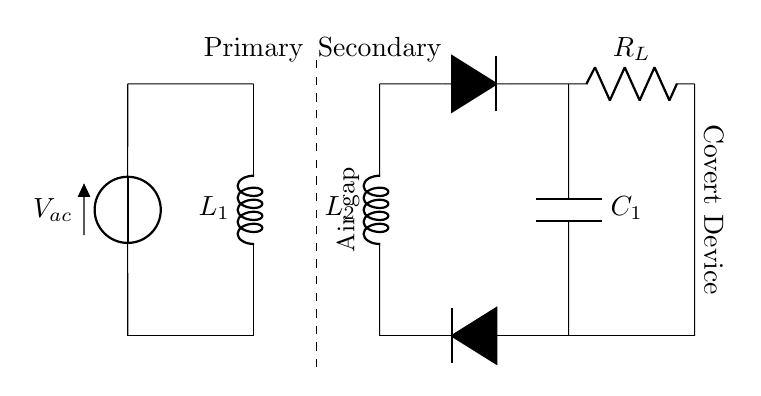What type of coils are used in this circuit? The circuit diagram shows two inductors labeled L1 and L2, indicating that these are inductive components acting as coils.
Answer: Inductors What is the voltage source indicated in the circuit? The circuit diagram has a voltage source labeled V_ac connected to the primary coil, which means this is the alternating current source for the circuit.
Answer: Alternating current What does the dashed line represent in this circuit? The dashed line is labeled as "Air gap," which indicates the non-conductive space between the primary and secondary coils where inductive coupling occurs.
Answer: Air gap What is the function of the rectifier in this circuit? The rectifier, depicted by two diodes, converts the alternating current from the secondary coil into direct current for the load.
Answer: Converts AC to DC How many resistors are present in the circuit? The circuit features one resistor labeled R_L, indicating a load resistor connected to the converted direct current.
Answer: One resistor What is the relationship between L1 and L2 in this circuit? L1 is the primary coil that generates a magnetic field when connected to the voltage source, while L2 is the secondary coil that receives this magnetic field to induce a current, demonstrating mutual induction.
Answer: Mutual induction What type of device is implied at the output of the circuit? The label at the right end of the diagram identifies the output as a "Covert Device," suggesting that this circuit is designed to power a communication device hidden within an everyday object.
Answer: Covert communication device 